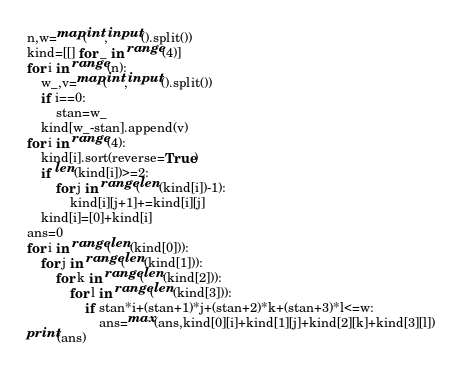Convert code to text. <code><loc_0><loc_0><loc_500><loc_500><_Python_>n,w=map(int,input().split())
kind=[[] for _ in range(4)]
for i in range(n):
    w_,v=map(int,input().split())
    if i==0:
        stan=w_
    kind[w_-stan].append(v)
for i in range(4):
    kind[i].sort(reverse=True)
    if len(kind[i])>=2:
        for j in range(len(kind[i])-1):
            kind[i][j+1]+=kind[i][j]
    kind[i]=[0]+kind[i]
ans=0
for i in range(len(kind[0])):
    for j in range(len(kind[1])):
        for k in range(len(kind[2])):
            for l in range(len(kind[3])):
                if stan*i+(stan+1)*j+(stan+2)*k+(stan+3)*l<=w:
                    ans=max(ans,kind[0][i]+kind[1][j]+kind[2][k]+kind[3][l])
print(ans)</code> 